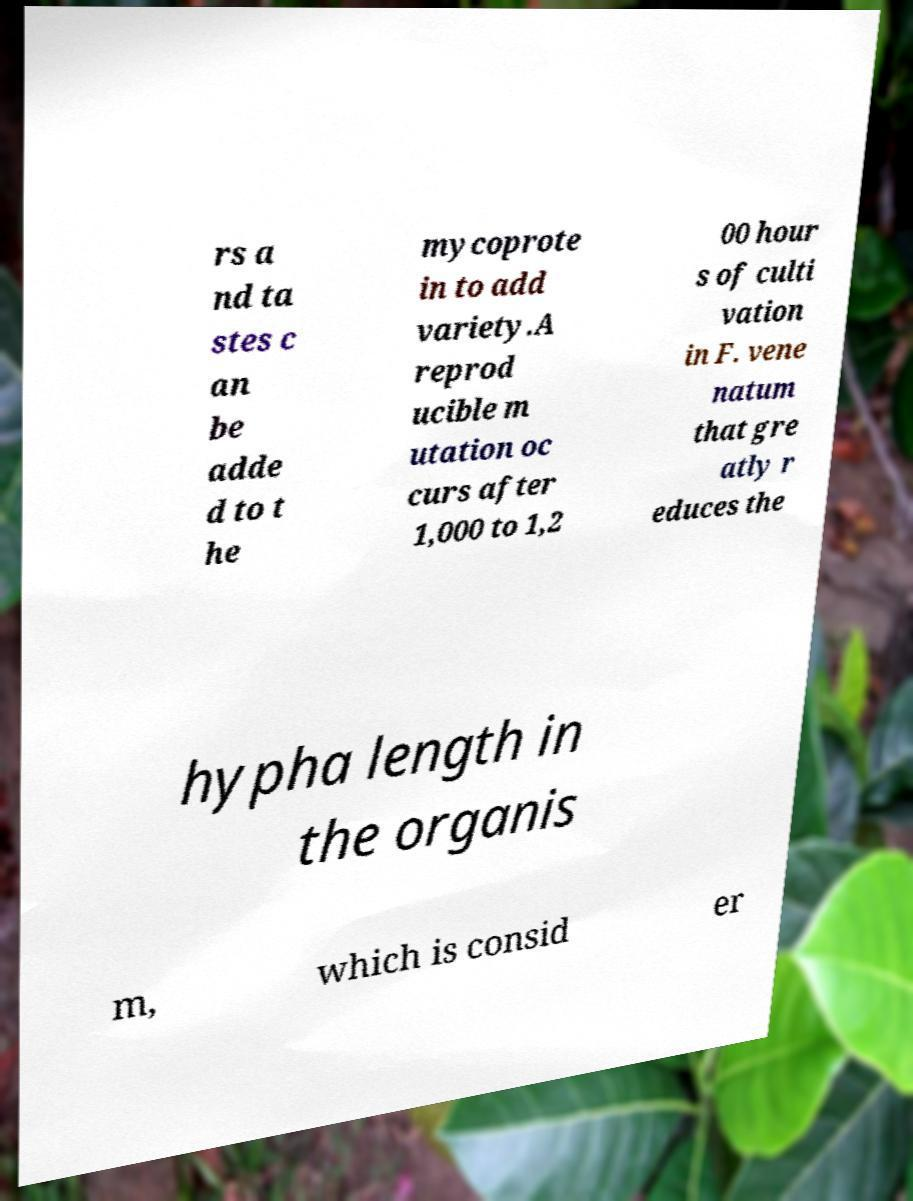Can you read and provide the text displayed in the image?This photo seems to have some interesting text. Can you extract and type it out for me? rs a nd ta stes c an be adde d to t he mycoprote in to add variety.A reprod ucible m utation oc curs after 1,000 to 1,2 00 hour s of culti vation in F. vene natum that gre atly r educes the hypha length in the organis m, which is consid er 